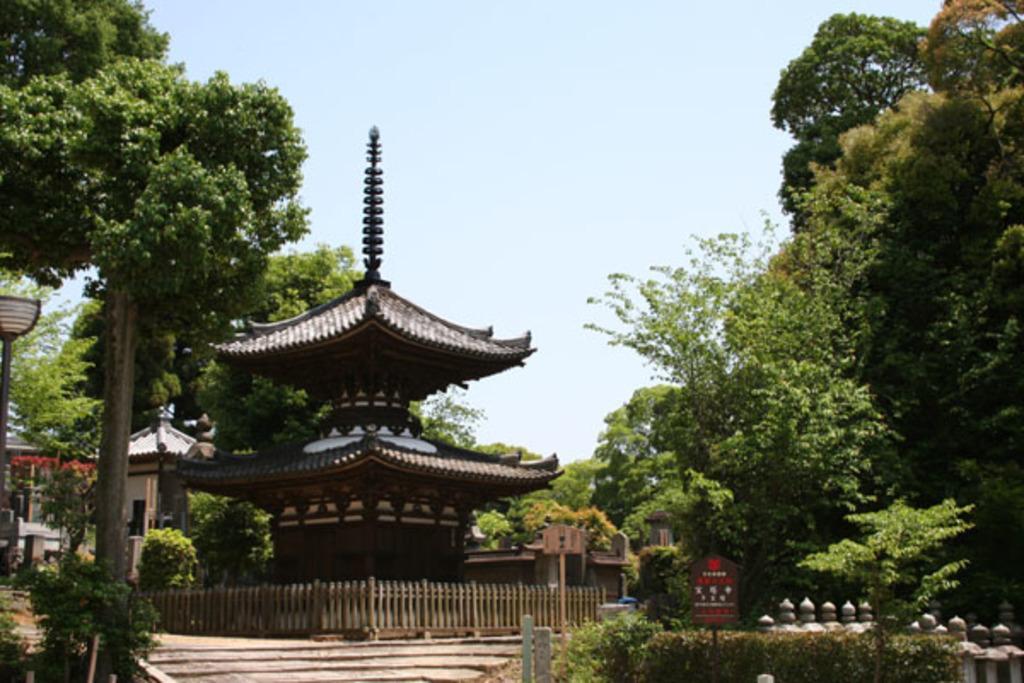How would you summarize this image in a sentence or two? In this image in the center there are some buildings, trees, fence, poles and some boards. At the bottom thee are some plants, at the top of the image there is sky. 